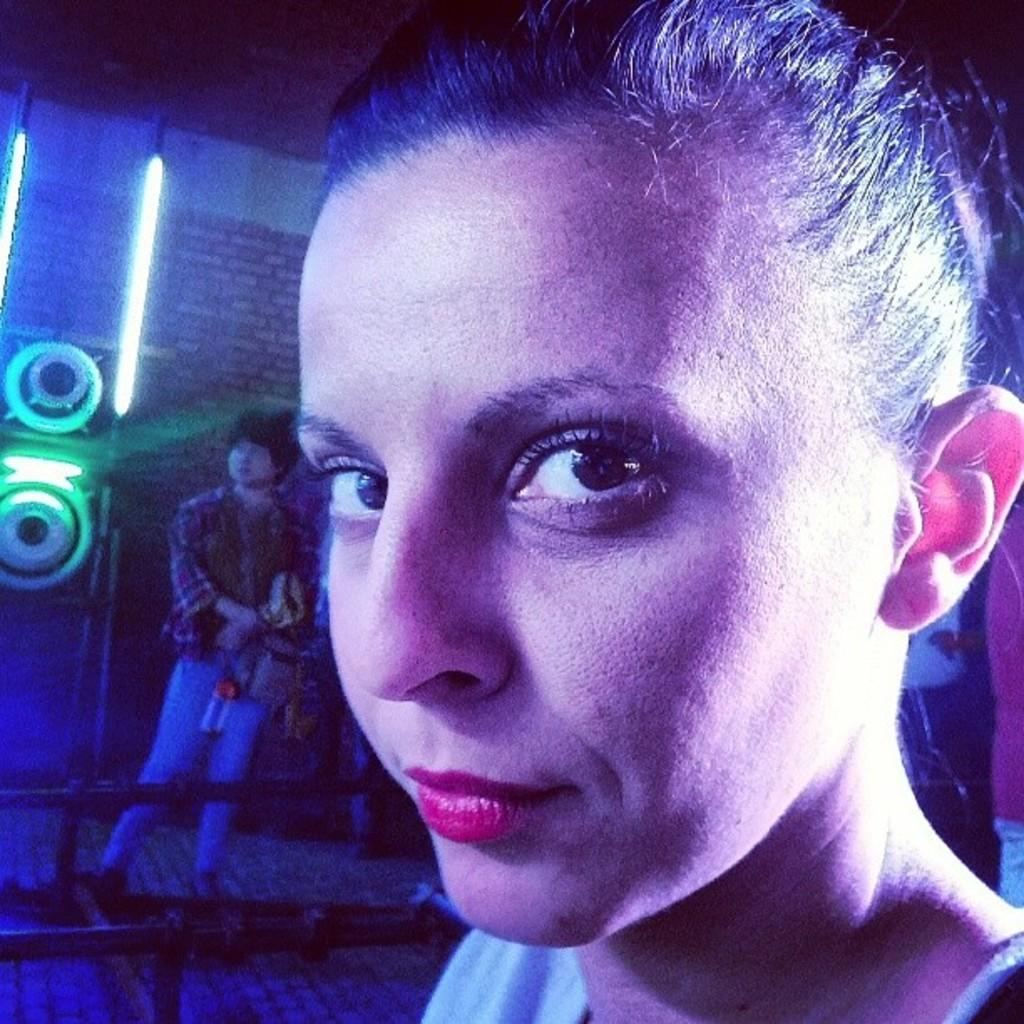How many people are present in the image? There is a woman and a man in the image. What type of structure can be seen in the image? There is a building in the image. What can be seen illuminating the scene in the image? There are lights visible in the image. What type of comb is the woman using to style her hair in the image? There is no comb visible in the image, and the woman's hair is not being styled. 